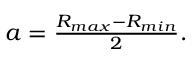<formula> <loc_0><loc_0><loc_500><loc_500>\begin{array} { r } { a = \frac { R _ { \max } - R _ { \min } } { 2 } . } \end{array}</formula> 